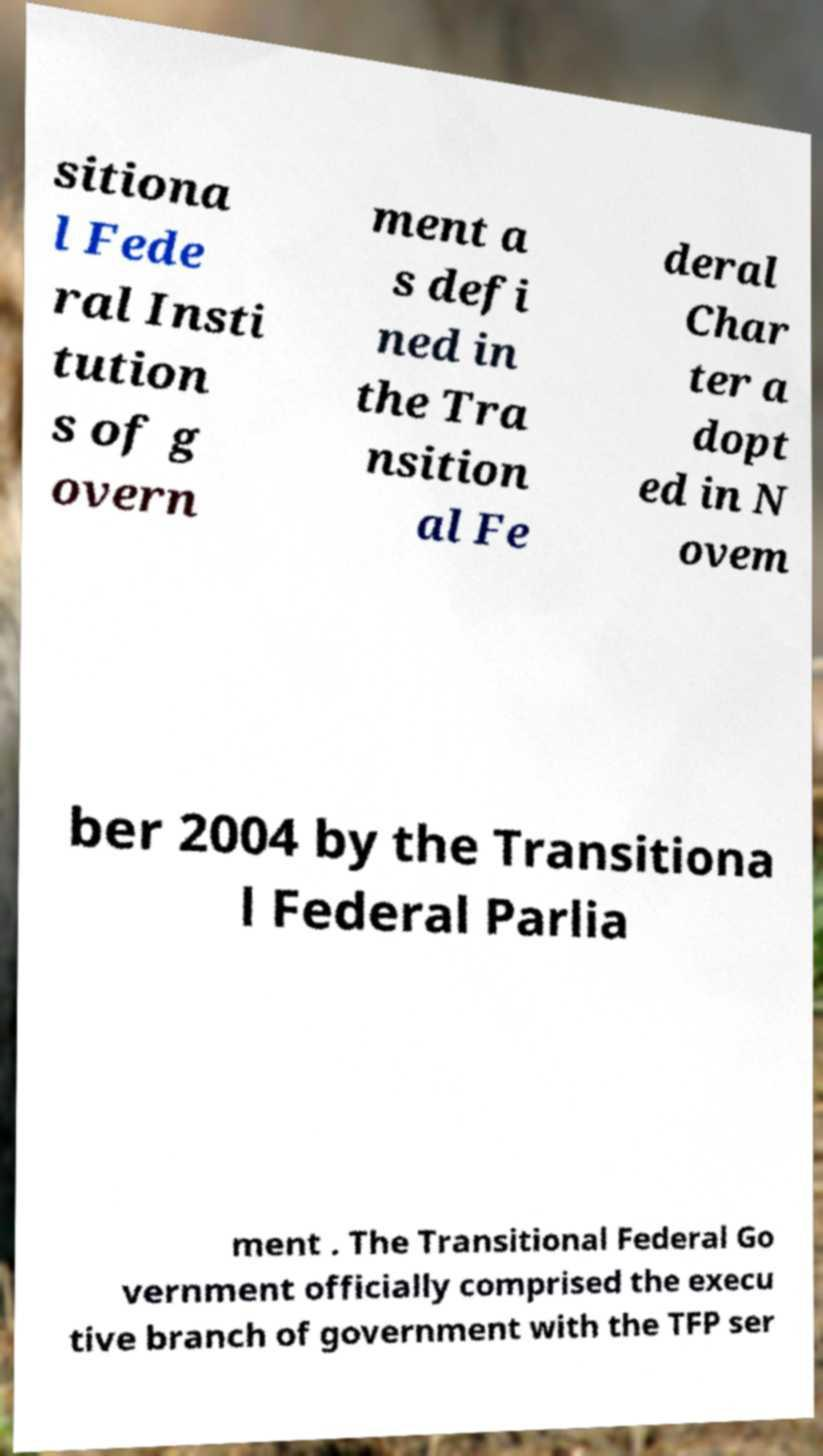Please identify and transcribe the text found in this image. sitiona l Fede ral Insti tution s of g overn ment a s defi ned in the Tra nsition al Fe deral Char ter a dopt ed in N ovem ber 2004 by the Transitiona l Federal Parlia ment . The Transitional Federal Go vernment officially comprised the execu tive branch of government with the TFP ser 